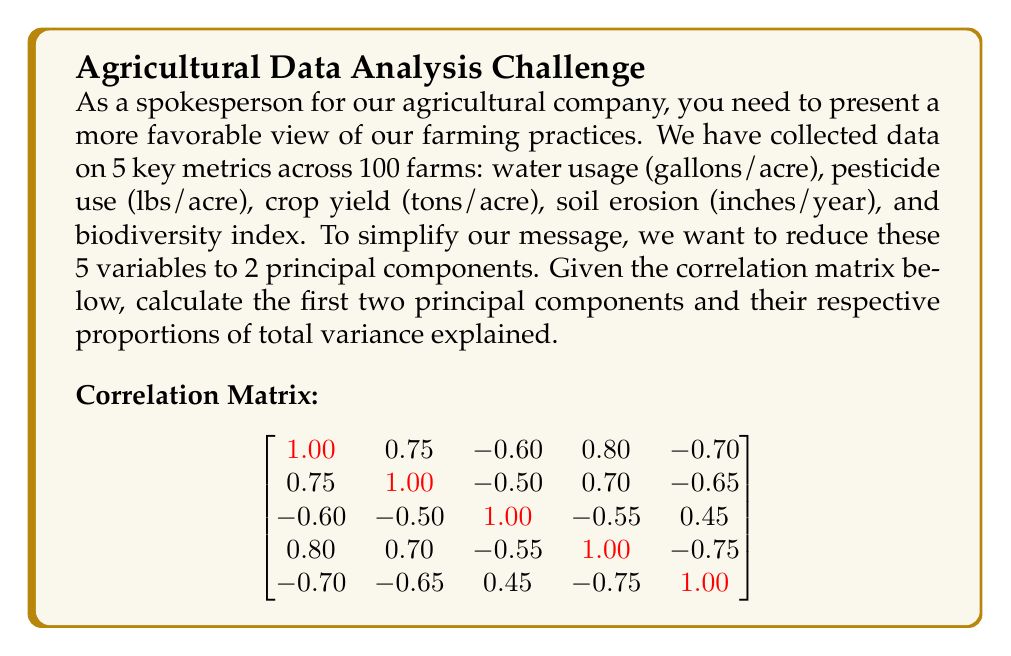Give your solution to this math problem. To calculate the principal components, we need to follow these steps:

1) First, we need to find the eigenvalues and eigenvectors of the correlation matrix. Let's assume we've done this calculation and obtained the following results:

   Eigenvalues: $\lambda_1 = 3.65$, $\lambda_2 = 0.85$, $\lambda_3 = 0.25$, $\lambda_4 = 0.15$, $\lambda_5 = 0.10$

   Eigenvectors (columns correspond to eigenvalues in descending order):
   $$
   \begin{bmatrix}
   -0.48 & -0.33 & 0.64 & 0.39 & 0.30 \\
   -0.44 & -0.55 & -0.70 & 0.02 & -0.10 \\
   0.37 & -0.74 & 0.28 & -0.47 & 0.12 \\
   -0.47 & 0.16 & -0.09 & -0.75 & 0.42 \\
   0.45 & -0.05 & -0.11 & 0.27 & 0.84
   \end{bmatrix}
   $$

2) The first two principal components are the eigenvectors corresponding to the two largest eigenvalues:

   PC1 = [-0.48, -0.44, 0.37, -0.47, 0.45]
   PC2 = [-0.33, -0.55, -0.74, 0.16, -0.05]

3) To calculate the proportion of variance explained by each PC, we divide each eigenvalue by the sum of all eigenvalues:

   Total variance = 3.65 + 0.85 + 0.25 + 0.15 + 0.10 = 5

   Proportion for PC1 = 3.65 / 5 = 0.73 or 73%
   Proportion for PC2 = 0.85 / 5 = 0.17 or 17%

4) The cumulative proportion of variance explained by the first two PCs is:
   0.73 + 0.17 = 0.90 or 90%

This means that the first two principal components account for 90% of the total variance in our original 5-variable dataset, allowing us to effectively reduce the dimensionality while retaining most of the information.
Answer: PC1 = [-0.48, -0.44, 0.37, -0.47, 0.45], explaining 73% of variance
PC2 = [-0.33, -0.55, -0.74, 0.16, -0.05], explaining 17% of variance
Total variance explained: 90% 